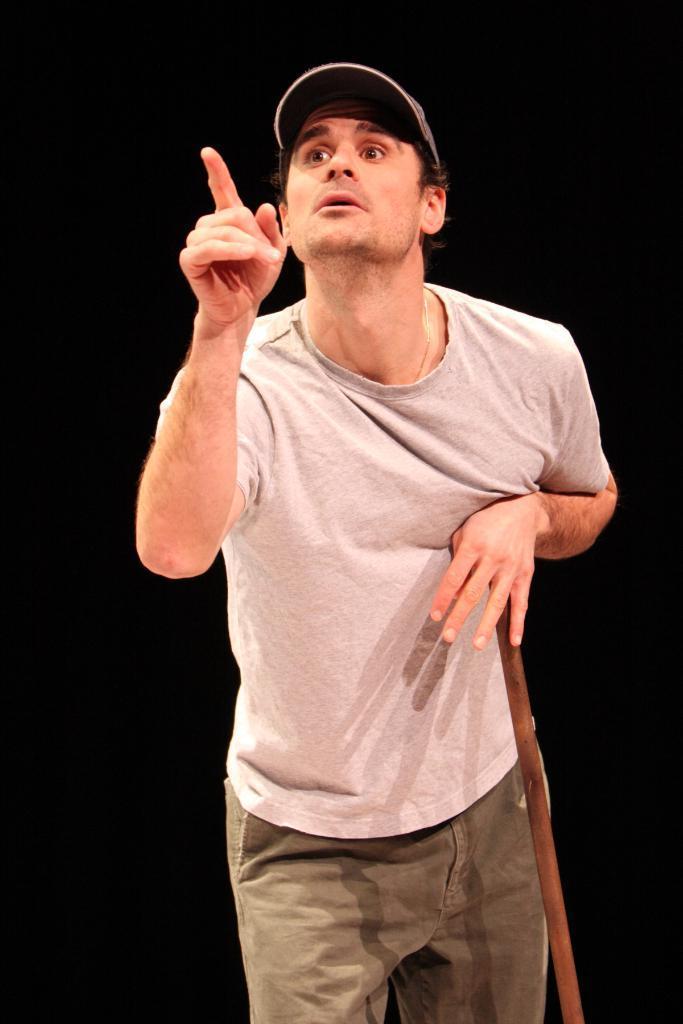Can you describe this image briefly? In this image there is a man standing, he is holding a stick, he is wearing a cap, the background of the image is black in color. 